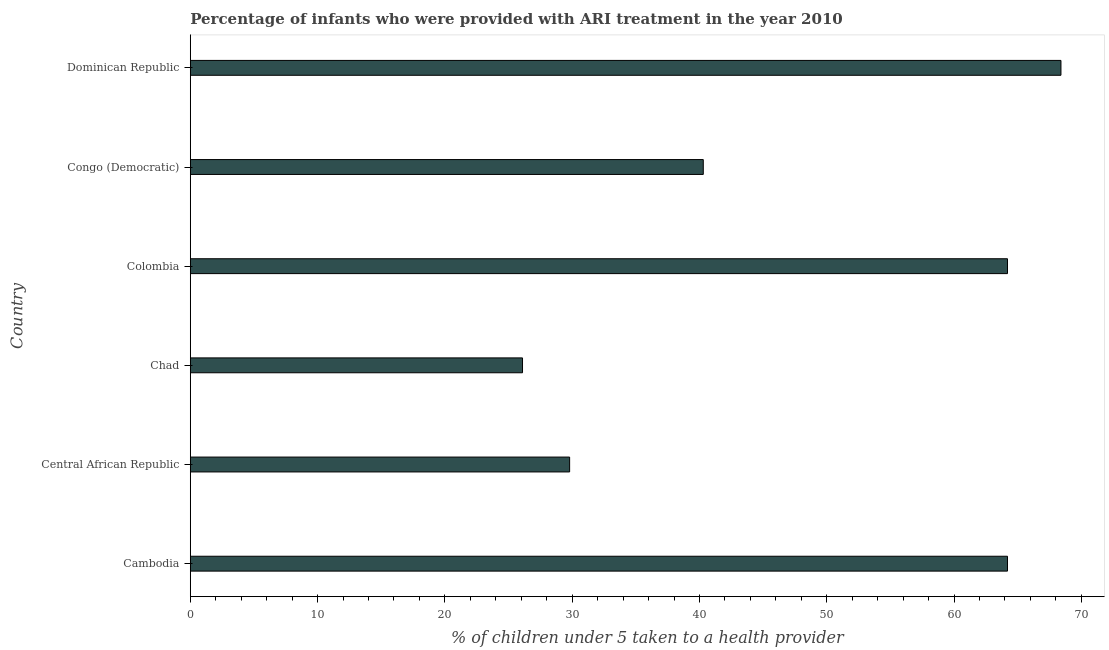Does the graph contain any zero values?
Offer a very short reply. No. What is the title of the graph?
Ensure brevity in your answer.  Percentage of infants who were provided with ARI treatment in the year 2010. What is the label or title of the X-axis?
Provide a short and direct response. % of children under 5 taken to a health provider. What is the percentage of children who were provided with ari treatment in Cambodia?
Keep it short and to the point. 64.2. Across all countries, what is the maximum percentage of children who were provided with ari treatment?
Provide a succinct answer. 68.4. Across all countries, what is the minimum percentage of children who were provided with ari treatment?
Your response must be concise. 26.1. In which country was the percentage of children who were provided with ari treatment maximum?
Ensure brevity in your answer.  Dominican Republic. In which country was the percentage of children who were provided with ari treatment minimum?
Offer a very short reply. Chad. What is the sum of the percentage of children who were provided with ari treatment?
Your response must be concise. 293. What is the difference between the percentage of children who were provided with ari treatment in Chad and Colombia?
Your response must be concise. -38.1. What is the average percentage of children who were provided with ari treatment per country?
Your answer should be compact. 48.83. What is the median percentage of children who were provided with ari treatment?
Make the answer very short. 52.25. What is the ratio of the percentage of children who were provided with ari treatment in Cambodia to that in Congo (Democratic)?
Offer a terse response. 1.59. Is the difference between the percentage of children who were provided with ari treatment in Cambodia and Chad greater than the difference between any two countries?
Your answer should be very brief. No. What is the difference between the highest and the lowest percentage of children who were provided with ari treatment?
Your response must be concise. 42.3. In how many countries, is the percentage of children who were provided with ari treatment greater than the average percentage of children who were provided with ari treatment taken over all countries?
Your answer should be very brief. 3. How many bars are there?
Your answer should be very brief. 6. What is the % of children under 5 taken to a health provider of Cambodia?
Give a very brief answer. 64.2. What is the % of children under 5 taken to a health provider of Central African Republic?
Provide a short and direct response. 29.8. What is the % of children under 5 taken to a health provider of Chad?
Your answer should be very brief. 26.1. What is the % of children under 5 taken to a health provider in Colombia?
Give a very brief answer. 64.2. What is the % of children under 5 taken to a health provider of Congo (Democratic)?
Give a very brief answer. 40.3. What is the % of children under 5 taken to a health provider in Dominican Republic?
Provide a short and direct response. 68.4. What is the difference between the % of children under 5 taken to a health provider in Cambodia and Central African Republic?
Your response must be concise. 34.4. What is the difference between the % of children under 5 taken to a health provider in Cambodia and Chad?
Your response must be concise. 38.1. What is the difference between the % of children under 5 taken to a health provider in Cambodia and Congo (Democratic)?
Provide a succinct answer. 23.9. What is the difference between the % of children under 5 taken to a health provider in Cambodia and Dominican Republic?
Your answer should be compact. -4.2. What is the difference between the % of children under 5 taken to a health provider in Central African Republic and Chad?
Provide a succinct answer. 3.7. What is the difference between the % of children under 5 taken to a health provider in Central African Republic and Colombia?
Provide a succinct answer. -34.4. What is the difference between the % of children under 5 taken to a health provider in Central African Republic and Congo (Democratic)?
Ensure brevity in your answer.  -10.5. What is the difference between the % of children under 5 taken to a health provider in Central African Republic and Dominican Republic?
Keep it short and to the point. -38.6. What is the difference between the % of children under 5 taken to a health provider in Chad and Colombia?
Give a very brief answer. -38.1. What is the difference between the % of children under 5 taken to a health provider in Chad and Dominican Republic?
Make the answer very short. -42.3. What is the difference between the % of children under 5 taken to a health provider in Colombia and Congo (Democratic)?
Provide a short and direct response. 23.9. What is the difference between the % of children under 5 taken to a health provider in Colombia and Dominican Republic?
Make the answer very short. -4.2. What is the difference between the % of children under 5 taken to a health provider in Congo (Democratic) and Dominican Republic?
Your answer should be very brief. -28.1. What is the ratio of the % of children under 5 taken to a health provider in Cambodia to that in Central African Republic?
Your answer should be compact. 2.15. What is the ratio of the % of children under 5 taken to a health provider in Cambodia to that in Chad?
Keep it short and to the point. 2.46. What is the ratio of the % of children under 5 taken to a health provider in Cambodia to that in Congo (Democratic)?
Make the answer very short. 1.59. What is the ratio of the % of children under 5 taken to a health provider in Cambodia to that in Dominican Republic?
Provide a short and direct response. 0.94. What is the ratio of the % of children under 5 taken to a health provider in Central African Republic to that in Chad?
Your answer should be compact. 1.14. What is the ratio of the % of children under 5 taken to a health provider in Central African Republic to that in Colombia?
Provide a short and direct response. 0.46. What is the ratio of the % of children under 5 taken to a health provider in Central African Republic to that in Congo (Democratic)?
Provide a succinct answer. 0.74. What is the ratio of the % of children under 5 taken to a health provider in Central African Republic to that in Dominican Republic?
Offer a very short reply. 0.44. What is the ratio of the % of children under 5 taken to a health provider in Chad to that in Colombia?
Keep it short and to the point. 0.41. What is the ratio of the % of children under 5 taken to a health provider in Chad to that in Congo (Democratic)?
Give a very brief answer. 0.65. What is the ratio of the % of children under 5 taken to a health provider in Chad to that in Dominican Republic?
Ensure brevity in your answer.  0.38. What is the ratio of the % of children under 5 taken to a health provider in Colombia to that in Congo (Democratic)?
Give a very brief answer. 1.59. What is the ratio of the % of children under 5 taken to a health provider in Colombia to that in Dominican Republic?
Ensure brevity in your answer.  0.94. What is the ratio of the % of children under 5 taken to a health provider in Congo (Democratic) to that in Dominican Republic?
Offer a terse response. 0.59. 